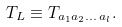Convert formula to latex. <formula><loc_0><loc_0><loc_500><loc_500>T _ { L } \equiv T _ { a _ { 1 } a _ { 2 } \dots \, a _ { l } } .</formula> 